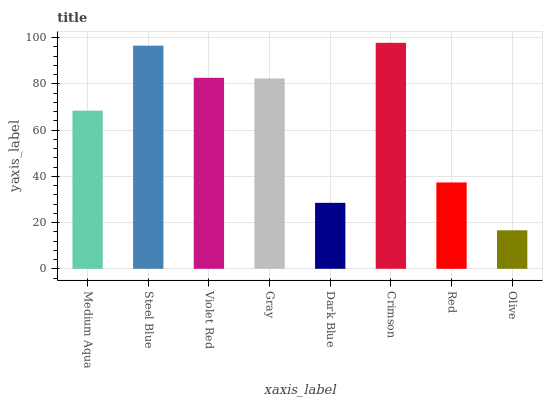Is Olive the minimum?
Answer yes or no. Yes. Is Crimson the maximum?
Answer yes or no. Yes. Is Steel Blue the minimum?
Answer yes or no. No. Is Steel Blue the maximum?
Answer yes or no. No. Is Steel Blue greater than Medium Aqua?
Answer yes or no. Yes. Is Medium Aqua less than Steel Blue?
Answer yes or no. Yes. Is Medium Aqua greater than Steel Blue?
Answer yes or no. No. Is Steel Blue less than Medium Aqua?
Answer yes or no. No. Is Gray the high median?
Answer yes or no. Yes. Is Medium Aqua the low median?
Answer yes or no. Yes. Is Olive the high median?
Answer yes or no. No. Is Steel Blue the low median?
Answer yes or no. No. 